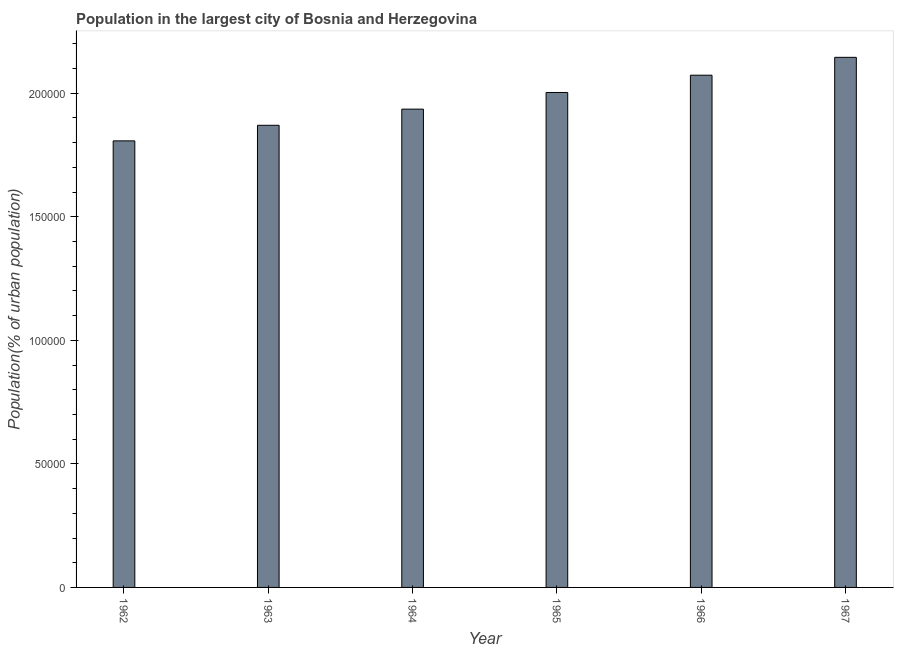What is the title of the graph?
Offer a terse response. Population in the largest city of Bosnia and Herzegovina. What is the label or title of the Y-axis?
Your answer should be compact. Population(% of urban population). What is the population in largest city in 1964?
Offer a very short reply. 1.94e+05. Across all years, what is the maximum population in largest city?
Your answer should be very brief. 2.15e+05. Across all years, what is the minimum population in largest city?
Your answer should be compact. 1.81e+05. In which year was the population in largest city maximum?
Give a very brief answer. 1967. What is the sum of the population in largest city?
Provide a short and direct response. 1.18e+06. What is the difference between the population in largest city in 1963 and 1965?
Keep it short and to the point. -1.33e+04. What is the average population in largest city per year?
Provide a short and direct response. 1.97e+05. What is the median population in largest city?
Keep it short and to the point. 1.97e+05. In how many years, is the population in largest city greater than 150000 %?
Ensure brevity in your answer.  6. What is the difference between the highest and the second highest population in largest city?
Keep it short and to the point. 7234. Is the sum of the population in largest city in 1964 and 1967 greater than the maximum population in largest city across all years?
Make the answer very short. Yes. What is the difference between the highest and the lowest population in largest city?
Your response must be concise. 3.38e+04. In how many years, is the population in largest city greater than the average population in largest city taken over all years?
Offer a very short reply. 3. Are all the bars in the graph horizontal?
Provide a succinct answer. No. How many years are there in the graph?
Give a very brief answer. 6. What is the difference between two consecutive major ticks on the Y-axis?
Offer a very short reply. 5.00e+04. Are the values on the major ticks of Y-axis written in scientific E-notation?
Your answer should be compact. No. What is the Population(% of urban population) of 1962?
Make the answer very short. 1.81e+05. What is the Population(% of urban population) in 1963?
Your answer should be very brief. 1.87e+05. What is the Population(% of urban population) of 1964?
Provide a succinct answer. 1.94e+05. What is the Population(% of urban population) in 1965?
Offer a very short reply. 2.00e+05. What is the Population(% of urban population) of 1966?
Give a very brief answer. 2.07e+05. What is the Population(% of urban population) in 1967?
Offer a terse response. 2.15e+05. What is the difference between the Population(% of urban population) in 1962 and 1963?
Your answer should be compact. -6306. What is the difference between the Population(% of urban population) in 1962 and 1964?
Provide a succinct answer. -1.28e+04. What is the difference between the Population(% of urban population) in 1962 and 1965?
Make the answer very short. -1.96e+04. What is the difference between the Population(% of urban population) in 1962 and 1966?
Your answer should be compact. -2.66e+04. What is the difference between the Population(% of urban population) in 1962 and 1967?
Provide a short and direct response. -3.38e+04. What is the difference between the Population(% of urban population) in 1963 and 1964?
Provide a short and direct response. -6536. What is the difference between the Population(% of urban population) in 1963 and 1965?
Keep it short and to the point. -1.33e+04. What is the difference between the Population(% of urban population) in 1963 and 1966?
Offer a terse response. -2.03e+04. What is the difference between the Population(% of urban population) in 1963 and 1967?
Your answer should be very brief. -2.75e+04. What is the difference between the Population(% of urban population) in 1964 and 1965?
Give a very brief answer. -6744. What is the difference between the Population(% of urban population) in 1964 and 1966?
Keep it short and to the point. -1.37e+04. What is the difference between the Population(% of urban population) in 1964 and 1967?
Offer a terse response. -2.10e+04. What is the difference between the Population(% of urban population) in 1965 and 1966?
Make the answer very short. -6990. What is the difference between the Population(% of urban population) in 1965 and 1967?
Make the answer very short. -1.42e+04. What is the difference between the Population(% of urban population) in 1966 and 1967?
Provide a short and direct response. -7234. What is the ratio of the Population(% of urban population) in 1962 to that in 1963?
Your answer should be compact. 0.97. What is the ratio of the Population(% of urban population) in 1962 to that in 1964?
Provide a short and direct response. 0.93. What is the ratio of the Population(% of urban population) in 1962 to that in 1965?
Your answer should be very brief. 0.9. What is the ratio of the Population(% of urban population) in 1962 to that in 1966?
Your answer should be compact. 0.87. What is the ratio of the Population(% of urban population) in 1962 to that in 1967?
Provide a succinct answer. 0.84. What is the ratio of the Population(% of urban population) in 1963 to that in 1964?
Your response must be concise. 0.97. What is the ratio of the Population(% of urban population) in 1963 to that in 1965?
Offer a terse response. 0.93. What is the ratio of the Population(% of urban population) in 1963 to that in 1966?
Give a very brief answer. 0.9. What is the ratio of the Population(% of urban population) in 1963 to that in 1967?
Offer a terse response. 0.87. What is the ratio of the Population(% of urban population) in 1964 to that in 1965?
Offer a very short reply. 0.97. What is the ratio of the Population(% of urban population) in 1964 to that in 1966?
Keep it short and to the point. 0.93. What is the ratio of the Population(% of urban population) in 1964 to that in 1967?
Your answer should be very brief. 0.9. What is the ratio of the Population(% of urban population) in 1965 to that in 1967?
Make the answer very short. 0.93. 